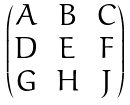<formula> <loc_0><loc_0><loc_500><loc_500>\begin{pmatrix} A & B & C \\ D & E & F \\ G & H & J \\ \end{pmatrix}</formula> 